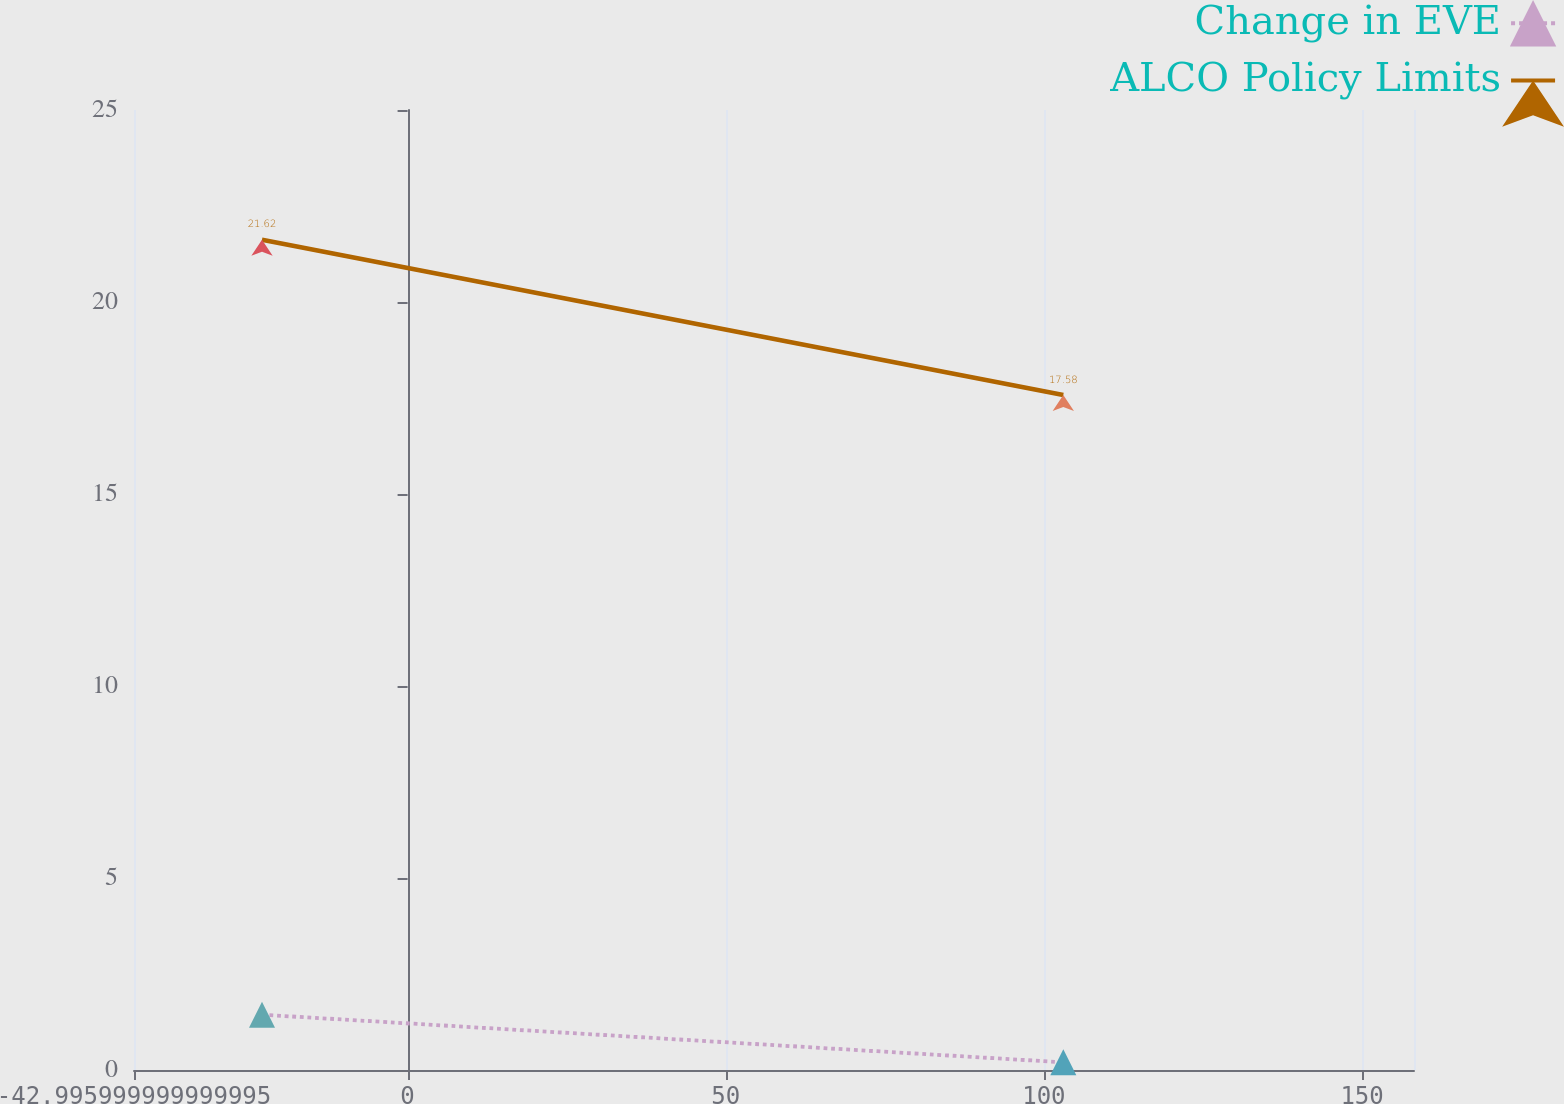Convert chart. <chart><loc_0><loc_0><loc_500><loc_500><line_chart><ecel><fcel>Change in EVE<fcel>ALCO Policy Limits<nl><fcel>-22.88<fcel>1.44<fcel>21.62<nl><fcel>103.05<fcel>0.2<fcel>17.58<nl><fcel>178.28<fcel>0.06<fcel>22.05<nl></chart> 